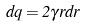Convert formula to latex. <formula><loc_0><loc_0><loc_500><loc_500>d q = 2 \gamma r d r</formula> 